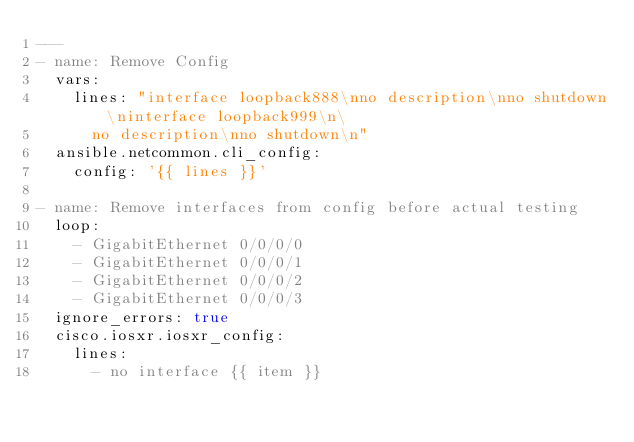Convert code to text. <code><loc_0><loc_0><loc_500><loc_500><_YAML_>---
- name: Remove Config
  vars:
    lines: "interface loopback888\nno description\nno shutdown\ninterface loopback999\n\
      no description\nno shutdown\n"
  ansible.netcommon.cli_config:
    config: '{{ lines }}'

- name: Remove interfaces from config before actual testing
  loop:
    - GigabitEthernet 0/0/0/0
    - GigabitEthernet 0/0/0/1
    - GigabitEthernet 0/0/0/2
    - GigabitEthernet 0/0/0/3
  ignore_errors: true
  cisco.iosxr.iosxr_config:
    lines:
      - no interface {{ item }}
</code> 